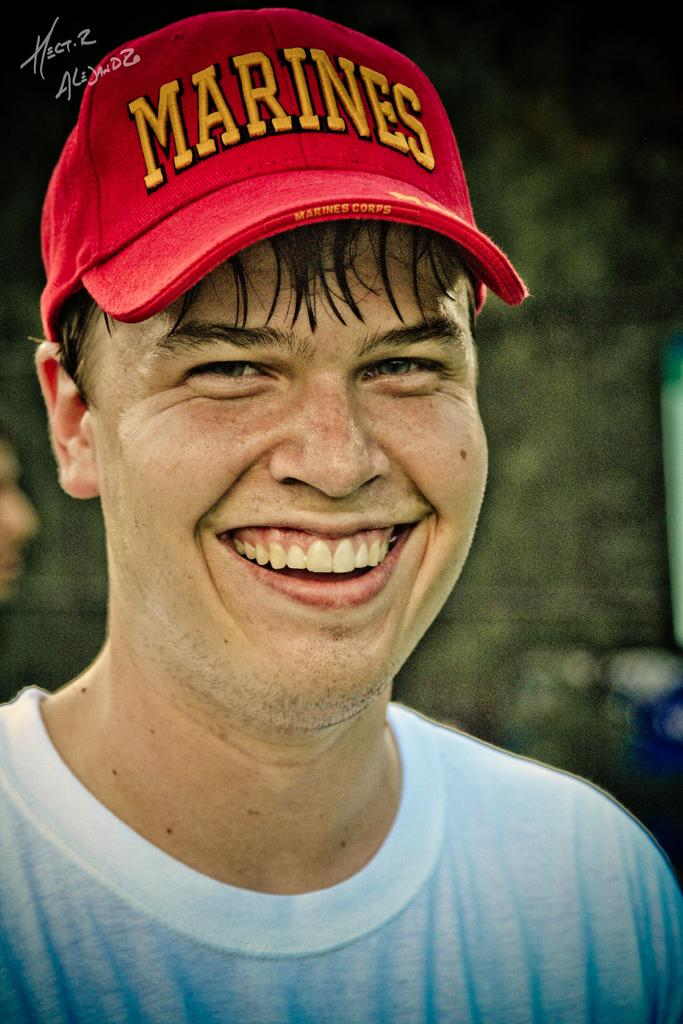What is the main subject of the image? There is a picture of a man in the image. How many fairies are flying around the man in the image? There are no fairies present in the image; it only features a picture of a man. What attraction is the man visiting in the image? The provided facts do not mention any specific attraction or location, so it cannot be determined from the image. 